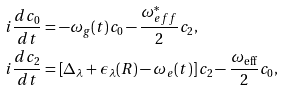Convert formula to latex. <formula><loc_0><loc_0><loc_500><loc_500>& i \frac { d c _ { 0 } } { d t } = - \omega _ { g } ( t ) c _ { 0 } - \frac { \omega _ { e f f } ^ { * } } { 2 } c _ { 2 } , \\ & i \frac { d c _ { 2 } } { d t } = \left [ \Delta _ { \lambda } + \epsilon _ { \lambda } ( R ) - \omega _ { e } ( t ) \right ] c _ { 2 } - \frac { \omega _ { \mathrm { e f f } } } { 2 } c _ { 0 } ,</formula> 